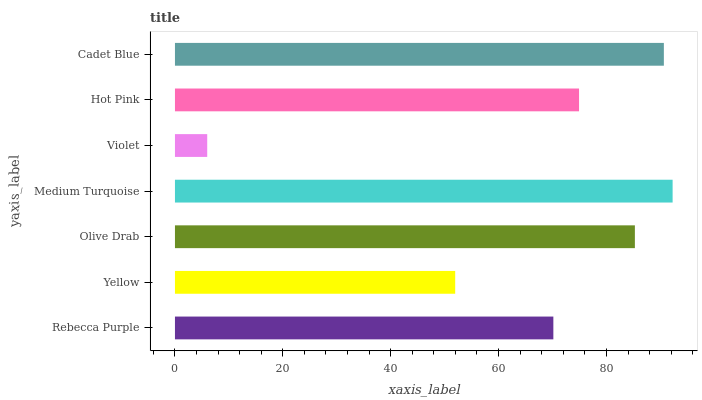Is Violet the minimum?
Answer yes or no. Yes. Is Medium Turquoise the maximum?
Answer yes or no. Yes. Is Yellow the minimum?
Answer yes or no. No. Is Yellow the maximum?
Answer yes or no. No. Is Rebecca Purple greater than Yellow?
Answer yes or no. Yes. Is Yellow less than Rebecca Purple?
Answer yes or no. Yes. Is Yellow greater than Rebecca Purple?
Answer yes or no. No. Is Rebecca Purple less than Yellow?
Answer yes or no. No. Is Hot Pink the high median?
Answer yes or no. Yes. Is Hot Pink the low median?
Answer yes or no. Yes. Is Violet the high median?
Answer yes or no. No. Is Medium Turquoise the low median?
Answer yes or no. No. 